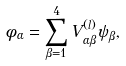<formula> <loc_0><loc_0><loc_500><loc_500>\phi _ { \alpha } = \sum _ { \beta = 1 } ^ { 4 } V ^ { ( l ) } _ { \alpha \beta } \psi _ { \beta } ,</formula> 